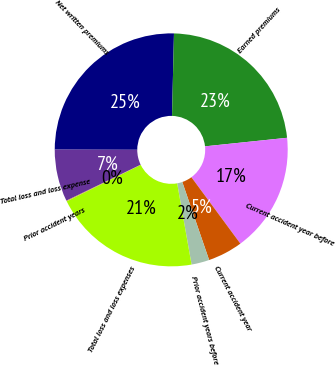<chart> <loc_0><loc_0><loc_500><loc_500><pie_chart><fcel>Net written premiums<fcel>Earned premiums<fcel>Current accident year before<fcel>Current accident year<fcel>Prior accident years before<fcel>Total loss and loss expenses<fcel>Prior accident years<fcel>Total loss and loss expense<nl><fcel>25.34%<fcel>22.97%<fcel>16.54%<fcel>4.84%<fcel>2.48%<fcel>20.51%<fcel>0.11%<fcel>7.21%<nl></chart> 